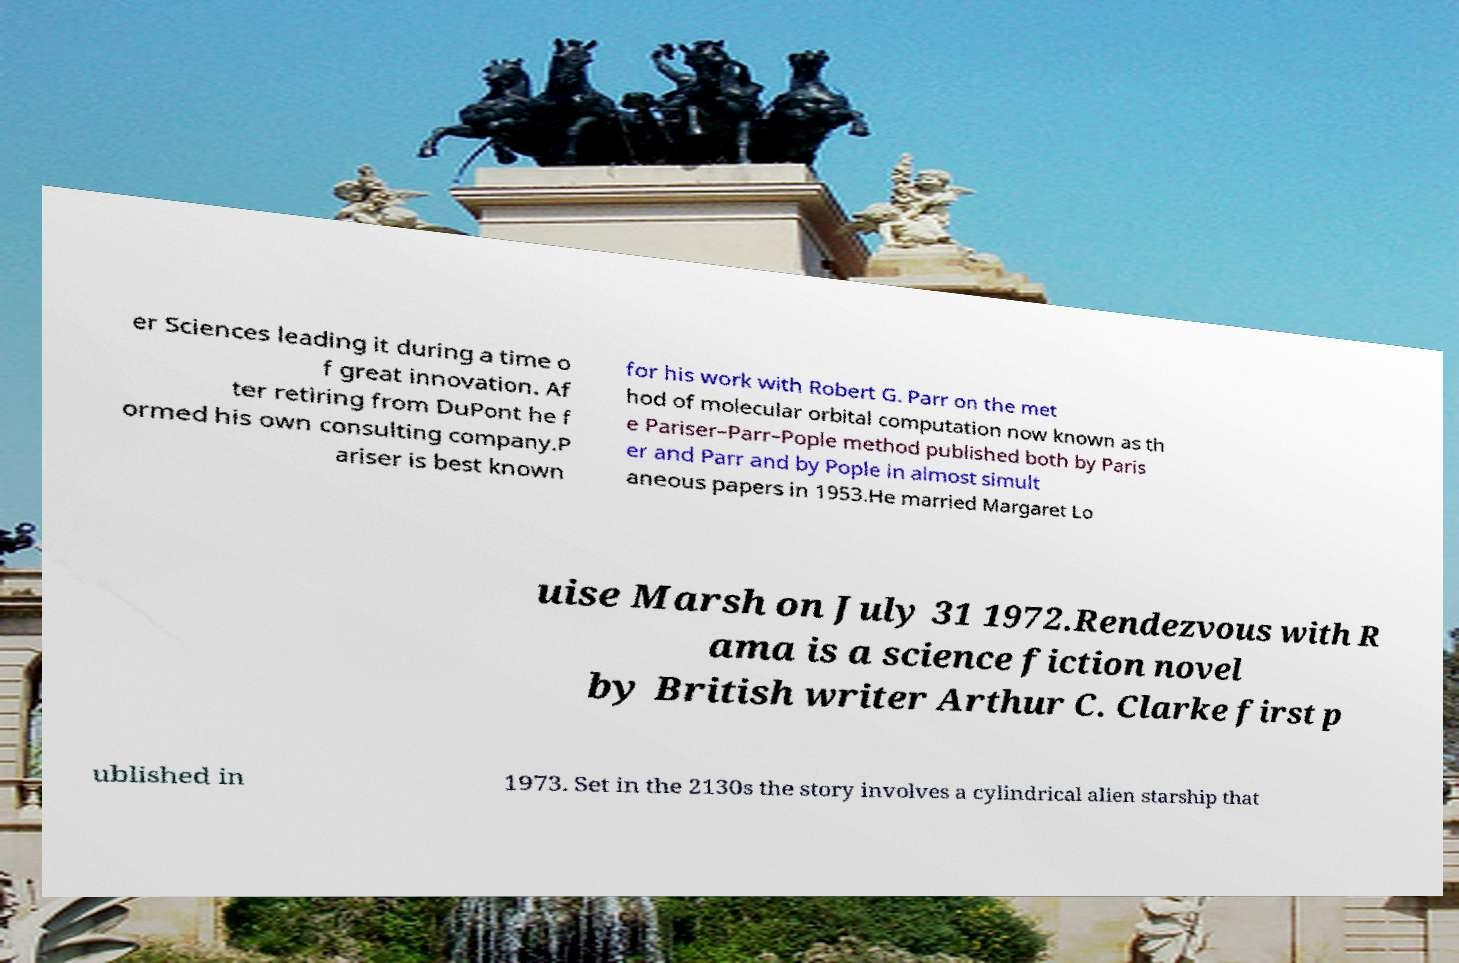What messages or text are displayed in this image? I need them in a readable, typed format. er Sciences leading it during a time o f great innovation. Af ter retiring from DuPont he f ormed his own consulting company.P ariser is best known for his work with Robert G. Parr on the met hod of molecular orbital computation now known as th e Pariser–Parr–Pople method published both by Paris er and Parr and by Pople in almost simult aneous papers in 1953.He married Margaret Lo uise Marsh on July 31 1972.Rendezvous with R ama is a science fiction novel by British writer Arthur C. Clarke first p ublished in 1973. Set in the 2130s the story involves a cylindrical alien starship that 